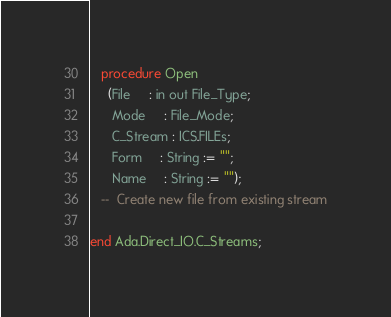<code> <loc_0><loc_0><loc_500><loc_500><_Ada_>
   procedure Open
     (File     : in out File_Type;
      Mode     : File_Mode;
      C_Stream : ICS.FILEs;
      Form     : String := "";
      Name     : String := "");
   --  Create new file from existing stream

end Ada.Direct_IO.C_Streams;
</code> 